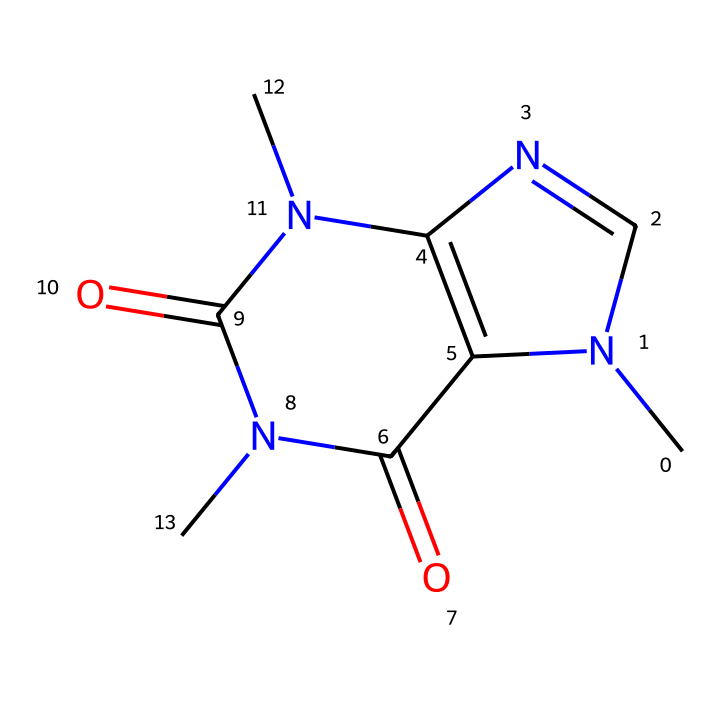What is the chemical name of this compound? The SMILES representation corresponds to caffeine, which is a well-known stimulant. By analyzing the structure, the arrangement of nitrogen, carbon, and oxygen atoms confirms this is caffeine.
Answer: caffeine How many nitrogen atoms are in caffeine? Looking at the SMILES representation, we can count two instances of 'N', indicating there are two nitrogen atoms present in the caffeine structure.
Answer: two What is the molecular formula of caffeine? By counting the atoms represented in the SMILES, we find there are 8 carbon atoms, 10 hydrogen atoms, 4 nitrogen atoms, and 2 oxygen atoms, leading to the molecular formula C8H10N4O2.
Answer: C8H10N4O2 What type of chemical is caffeine classified as? Caffeine is classified as an alkaloid due to its nitrogen-containing structure and its physiological effects on humans. The presence of nitrogen atoms in a cyclic formation supports this classification.
Answer: alkaloid Does caffeine contain any double bonds? Analyzing the structure from the SMILES notation reveals instances of '=' which represents double bonds. In caffeine, there are two domains where double bonds occur between Carbon and Oxygen.
Answer: yes What is the potential reason caffeine can act as a stimulant? The presence of nitrogen atoms in the structure contributes to its impact on neurotransmitter activity, primarily affecting adenosine receptors in the brain, enhancing alertness and reducing fatigue.
Answer: neurotransmitter Is caffeine a cyclic compound? The presence of multiple rings in the SMILES representation (indicated by '1' and '2') confirms that caffeine is indeed a cyclic compound due to its fused ring system.
Answer: yes 